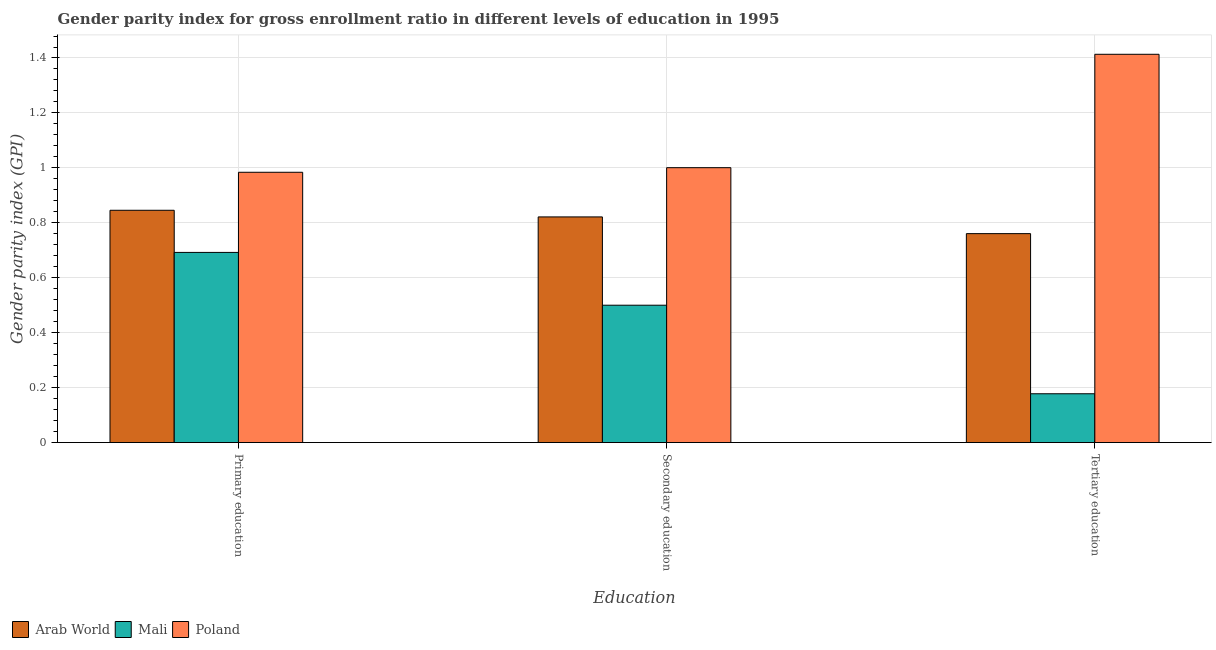How many different coloured bars are there?
Offer a very short reply. 3. How many groups of bars are there?
Your answer should be compact. 3. Are the number of bars per tick equal to the number of legend labels?
Ensure brevity in your answer.  Yes. What is the label of the 3rd group of bars from the left?
Your answer should be very brief. Tertiary education. What is the gender parity index in tertiary education in Mali?
Make the answer very short. 0.18. Across all countries, what is the minimum gender parity index in tertiary education?
Give a very brief answer. 0.18. In which country was the gender parity index in secondary education maximum?
Make the answer very short. Poland. In which country was the gender parity index in secondary education minimum?
Give a very brief answer. Mali. What is the total gender parity index in primary education in the graph?
Provide a succinct answer. 2.52. What is the difference between the gender parity index in secondary education in Arab World and that in Poland?
Your response must be concise. -0.18. What is the difference between the gender parity index in primary education in Mali and the gender parity index in secondary education in Arab World?
Make the answer very short. -0.13. What is the average gender parity index in tertiary education per country?
Keep it short and to the point. 0.78. What is the difference between the gender parity index in secondary education and gender parity index in primary education in Poland?
Give a very brief answer. 0.02. What is the ratio of the gender parity index in tertiary education in Mali to that in Poland?
Keep it short and to the point. 0.13. Is the difference between the gender parity index in secondary education in Arab World and Mali greater than the difference between the gender parity index in primary education in Arab World and Mali?
Make the answer very short. Yes. What is the difference between the highest and the second highest gender parity index in primary education?
Give a very brief answer. 0.14. What is the difference between the highest and the lowest gender parity index in tertiary education?
Your response must be concise. 1.24. In how many countries, is the gender parity index in secondary education greater than the average gender parity index in secondary education taken over all countries?
Make the answer very short. 2. Is the sum of the gender parity index in secondary education in Arab World and Poland greater than the maximum gender parity index in tertiary education across all countries?
Provide a short and direct response. Yes. What does the 3rd bar from the left in Secondary education represents?
Provide a succinct answer. Poland. What does the 3rd bar from the right in Primary education represents?
Your response must be concise. Arab World. How many bars are there?
Make the answer very short. 9. Are all the bars in the graph horizontal?
Ensure brevity in your answer.  No. Are the values on the major ticks of Y-axis written in scientific E-notation?
Provide a succinct answer. No. What is the title of the graph?
Ensure brevity in your answer.  Gender parity index for gross enrollment ratio in different levels of education in 1995. Does "Moldova" appear as one of the legend labels in the graph?
Provide a short and direct response. No. What is the label or title of the X-axis?
Your answer should be compact. Education. What is the label or title of the Y-axis?
Keep it short and to the point. Gender parity index (GPI). What is the Gender parity index (GPI) of Arab World in Primary education?
Keep it short and to the point. 0.85. What is the Gender parity index (GPI) of Mali in Primary education?
Your answer should be compact. 0.69. What is the Gender parity index (GPI) in Poland in Primary education?
Your answer should be very brief. 0.98. What is the Gender parity index (GPI) of Arab World in Secondary education?
Ensure brevity in your answer.  0.82. What is the Gender parity index (GPI) of Mali in Secondary education?
Give a very brief answer. 0.5. What is the Gender parity index (GPI) in Poland in Secondary education?
Provide a short and direct response. 1. What is the Gender parity index (GPI) of Arab World in Tertiary education?
Your answer should be compact. 0.76. What is the Gender parity index (GPI) in Mali in Tertiary education?
Offer a very short reply. 0.18. What is the Gender parity index (GPI) of Poland in Tertiary education?
Provide a succinct answer. 1.41. Across all Education, what is the maximum Gender parity index (GPI) in Arab World?
Give a very brief answer. 0.85. Across all Education, what is the maximum Gender parity index (GPI) of Mali?
Make the answer very short. 0.69. Across all Education, what is the maximum Gender parity index (GPI) of Poland?
Your answer should be very brief. 1.41. Across all Education, what is the minimum Gender parity index (GPI) of Arab World?
Keep it short and to the point. 0.76. Across all Education, what is the minimum Gender parity index (GPI) in Mali?
Your answer should be compact. 0.18. What is the total Gender parity index (GPI) of Arab World in the graph?
Give a very brief answer. 2.43. What is the total Gender parity index (GPI) of Mali in the graph?
Offer a terse response. 1.37. What is the total Gender parity index (GPI) in Poland in the graph?
Give a very brief answer. 3.4. What is the difference between the Gender parity index (GPI) of Arab World in Primary education and that in Secondary education?
Provide a succinct answer. 0.02. What is the difference between the Gender parity index (GPI) in Mali in Primary education and that in Secondary education?
Offer a terse response. 0.19. What is the difference between the Gender parity index (GPI) in Poland in Primary education and that in Secondary education?
Offer a very short reply. -0.02. What is the difference between the Gender parity index (GPI) of Arab World in Primary education and that in Tertiary education?
Give a very brief answer. 0.09. What is the difference between the Gender parity index (GPI) of Mali in Primary education and that in Tertiary education?
Ensure brevity in your answer.  0.51. What is the difference between the Gender parity index (GPI) of Poland in Primary education and that in Tertiary education?
Offer a very short reply. -0.43. What is the difference between the Gender parity index (GPI) in Arab World in Secondary education and that in Tertiary education?
Give a very brief answer. 0.06. What is the difference between the Gender parity index (GPI) in Mali in Secondary education and that in Tertiary education?
Provide a succinct answer. 0.32. What is the difference between the Gender parity index (GPI) of Poland in Secondary education and that in Tertiary education?
Offer a terse response. -0.41. What is the difference between the Gender parity index (GPI) in Arab World in Primary education and the Gender parity index (GPI) in Mali in Secondary education?
Keep it short and to the point. 0.35. What is the difference between the Gender parity index (GPI) in Arab World in Primary education and the Gender parity index (GPI) in Poland in Secondary education?
Keep it short and to the point. -0.15. What is the difference between the Gender parity index (GPI) in Mali in Primary education and the Gender parity index (GPI) in Poland in Secondary education?
Offer a terse response. -0.31. What is the difference between the Gender parity index (GPI) in Arab World in Primary education and the Gender parity index (GPI) in Mali in Tertiary education?
Offer a terse response. 0.67. What is the difference between the Gender parity index (GPI) of Arab World in Primary education and the Gender parity index (GPI) of Poland in Tertiary education?
Ensure brevity in your answer.  -0.57. What is the difference between the Gender parity index (GPI) of Mali in Primary education and the Gender parity index (GPI) of Poland in Tertiary education?
Provide a short and direct response. -0.72. What is the difference between the Gender parity index (GPI) in Arab World in Secondary education and the Gender parity index (GPI) in Mali in Tertiary education?
Offer a terse response. 0.64. What is the difference between the Gender parity index (GPI) in Arab World in Secondary education and the Gender parity index (GPI) in Poland in Tertiary education?
Your answer should be compact. -0.59. What is the difference between the Gender parity index (GPI) in Mali in Secondary education and the Gender parity index (GPI) in Poland in Tertiary education?
Give a very brief answer. -0.91. What is the average Gender parity index (GPI) in Arab World per Education?
Provide a succinct answer. 0.81. What is the average Gender parity index (GPI) of Mali per Education?
Give a very brief answer. 0.46. What is the average Gender parity index (GPI) in Poland per Education?
Provide a short and direct response. 1.13. What is the difference between the Gender parity index (GPI) in Arab World and Gender parity index (GPI) in Mali in Primary education?
Your answer should be very brief. 0.15. What is the difference between the Gender parity index (GPI) in Arab World and Gender parity index (GPI) in Poland in Primary education?
Offer a very short reply. -0.14. What is the difference between the Gender parity index (GPI) in Mali and Gender parity index (GPI) in Poland in Primary education?
Your answer should be very brief. -0.29. What is the difference between the Gender parity index (GPI) of Arab World and Gender parity index (GPI) of Mali in Secondary education?
Make the answer very short. 0.32. What is the difference between the Gender parity index (GPI) in Arab World and Gender parity index (GPI) in Poland in Secondary education?
Offer a very short reply. -0.18. What is the difference between the Gender parity index (GPI) in Mali and Gender parity index (GPI) in Poland in Secondary education?
Make the answer very short. -0.5. What is the difference between the Gender parity index (GPI) of Arab World and Gender parity index (GPI) of Mali in Tertiary education?
Give a very brief answer. 0.58. What is the difference between the Gender parity index (GPI) of Arab World and Gender parity index (GPI) of Poland in Tertiary education?
Offer a terse response. -0.65. What is the difference between the Gender parity index (GPI) of Mali and Gender parity index (GPI) of Poland in Tertiary education?
Give a very brief answer. -1.24. What is the ratio of the Gender parity index (GPI) in Arab World in Primary education to that in Secondary education?
Your response must be concise. 1.03. What is the ratio of the Gender parity index (GPI) in Mali in Primary education to that in Secondary education?
Your response must be concise. 1.38. What is the ratio of the Gender parity index (GPI) in Poland in Primary education to that in Secondary education?
Make the answer very short. 0.98. What is the ratio of the Gender parity index (GPI) in Arab World in Primary education to that in Tertiary education?
Ensure brevity in your answer.  1.11. What is the ratio of the Gender parity index (GPI) of Mali in Primary education to that in Tertiary education?
Offer a very short reply. 3.89. What is the ratio of the Gender parity index (GPI) in Poland in Primary education to that in Tertiary education?
Give a very brief answer. 0.7. What is the ratio of the Gender parity index (GPI) in Arab World in Secondary education to that in Tertiary education?
Your response must be concise. 1.08. What is the ratio of the Gender parity index (GPI) of Mali in Secondary education to that in Tertiary education?
Your response must be concise. 2.81. What is the ratio of the Gender parity index (GPI) in Poland in Secondary education to that in Tertiary education?
Offer a very short reply. 0.71. What is the difference between the highest and the second highest Gender parity index (GPI) of Arab World?
Your answer should be compact. 0.02. What is the difference between the highest and the second highest Gender parity index (GPI) in Mali?
Make the answer very short. 0.19. What is the difference between the highest and the second highest Gender parity index (GPI) of Poland?
Offer a very short reply. 0.41. What is the difference between the highest and the lowest Gender parity index (GPI) of Arab World?
Offer a terse response. 0.09. What is the difference between the highest and the lowest Gender parity index (GPI) of Mali?
Your answer should be very brief. 0.51. What is the difference between the highest and the lowest Gender parity index (GPI) of Poland?
Offer a terse response. 0.43. 